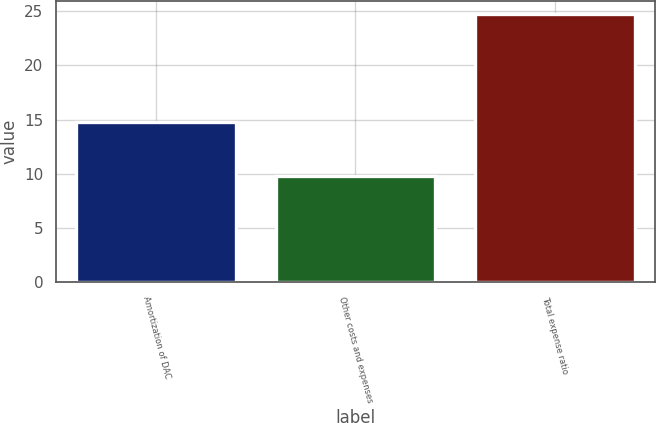<chart> <loc_0><loc_0><loc_500><loc_500><bar_chart><fcel>Amortization of DAC<fcel>Other costs and expenses<fcel>Total expense ratio<nl><fcel>14.8<fcel>9.8<fcel>24.7<nl></chart> 